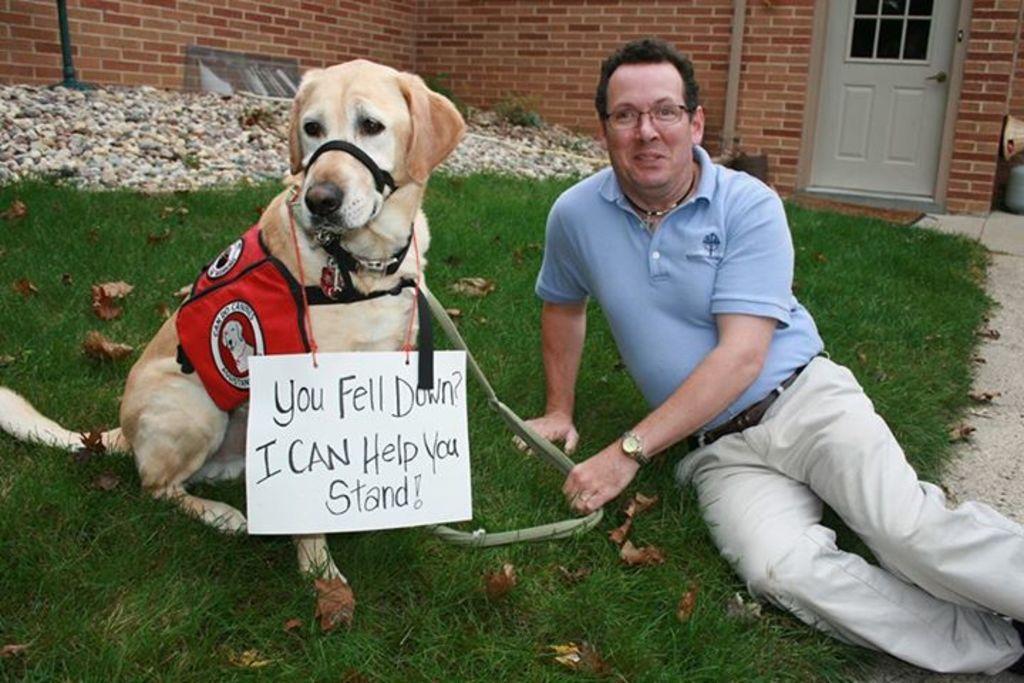Can you describe this image briefly? In this picture we can see a man who is sitting on the grass. He has spectacles and he wear a watch. This is the dog and there is a board. Here on the background we can see a door and this is the wall. 